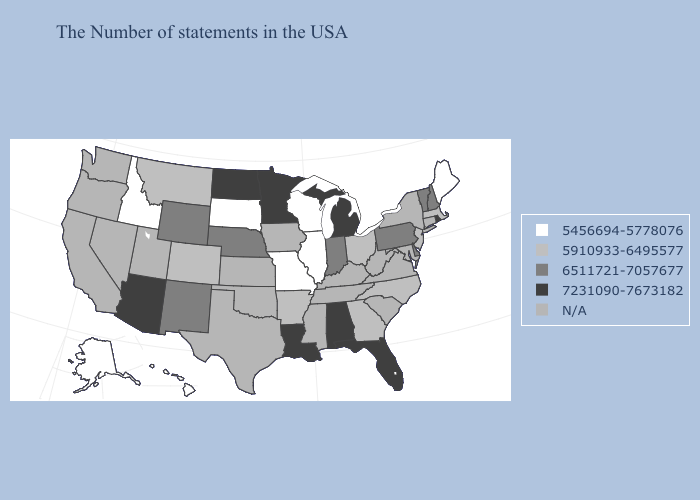What is the value of Washington?
Write a very short answer. N/A. What is the value of North Dakota?
Answer briefly. 7231090-7673182. Name the states that have a value in the range N/A?
Concise answer only. Connecticut, New York, Maryland, Virginia, South Carolina, West Virginia, Kentucky, Tennessee, Mississippi, Iowa, Kansas, Oklahoma, Texas, Utah, Nevada, California, Washington, Oregon. Does Vermont have the highest value in the USA?
Concise answer only. No. Which states have the highest value in the USA?
Short answer required. Rhode Island, Florida, Michigan, Alabama, Louisiana, Minnesota, North Dakota, Arizona. Name the states that have a value in the range 5910933-6495577?
Short answer required. Massachusetts, New Jersey, North Carolina, Ohio, Georgia, Arkansas, Colorado, Montana. What is the value of Utah?
Concise answer only. N/A. Name the states that have a value in the range 7231090-7673182?
Concise answer only. Rhode Island, Florida, Michigan, Alabama, Louisiana, Minnesota, North Dakota, Arizona. What is the value of California?
Concise answer only. N/A. Does the map have missing data?
Give a very brief answer. Yes. What is the lowest value in states that border New Hampshire?
Answer briefly. 5456694-5778076. Does the first symbol in the legend represent the smallest category?
Be succinct. Yes. Does Vermont have the highest value in the USA?
Answer briefly. No. What is the highest value in the USA?
Give a very brief answer. 7231090-7673182. Name the states that have a value in the range 5456694-5778076?
Give a very brief answer. Maine, Wisconsin, Illinois, Missouri, South Dakota, Idaho, Alaska, Hawaii. 